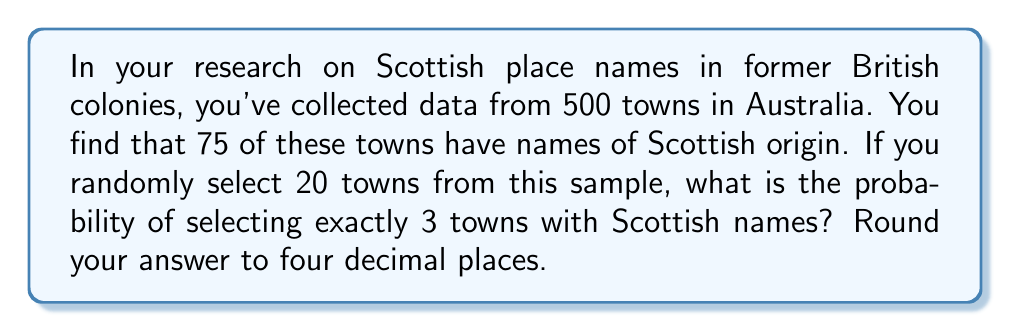Help me with this question. To solve this problem, we'll use the binomial probability formula, as we're dealing with a fixed number of independent trials (selecting 20 towns) where each trial has the same probability of success (having a Scottish name).

Step 1: Calculate the probability of a town having a Scottish name.
$p = \frac{75}{500} = 0.15$

Step 2: Calculate the probability of a town not having a Scottish name.
$q = 1 - p = 1 - 0.15 = 0.85$

Step 3: Use the binomial probability formula:
$$P(X = k) = \binom{n}{k} p^k q^{n-k}$$
Where:
$n = 20$ (number of towns selected)
$k = 3$ (number of successes we're looking for)
$p = 0.15$ (probability of success)
$q = 0.85$ (probability of failure)

Step 4: Calculate the binomial coefficient:
$$\binom{20}{3} = \frac{20!}{3!(20-3)!} = \frac{20!}{3!17!} = 1140$$

Step 5: Plug all values into the formula:
$$P(X = 3) = 1140 \cdot (0.15)^3 \cdot (0.85)^{17}$$

Step 6: Calculate the result:
$$P(X = 3) = 1140 \cdot 0.003375 \cdot 0.0412840997 \approx 0.1584$$

Step 7: Round to four decimal places:
$$P(X = 3) \approx 0.1584$$
Answer: 0.1584 